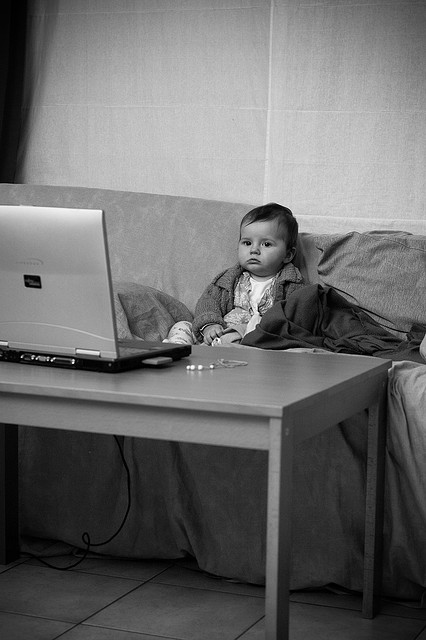<image>Is this an apple laptop? No, this is not an Apple laptop according to the majority of the given answers. However, one response provided is unsure. What color is the 'moustache'? There is no moustache in the image. What color is the 'moustache'? There is no 'moustache' in the image. Is this an apple laptop? I am not sure if this is an apple laptop. It can be seen as both yes and no. 